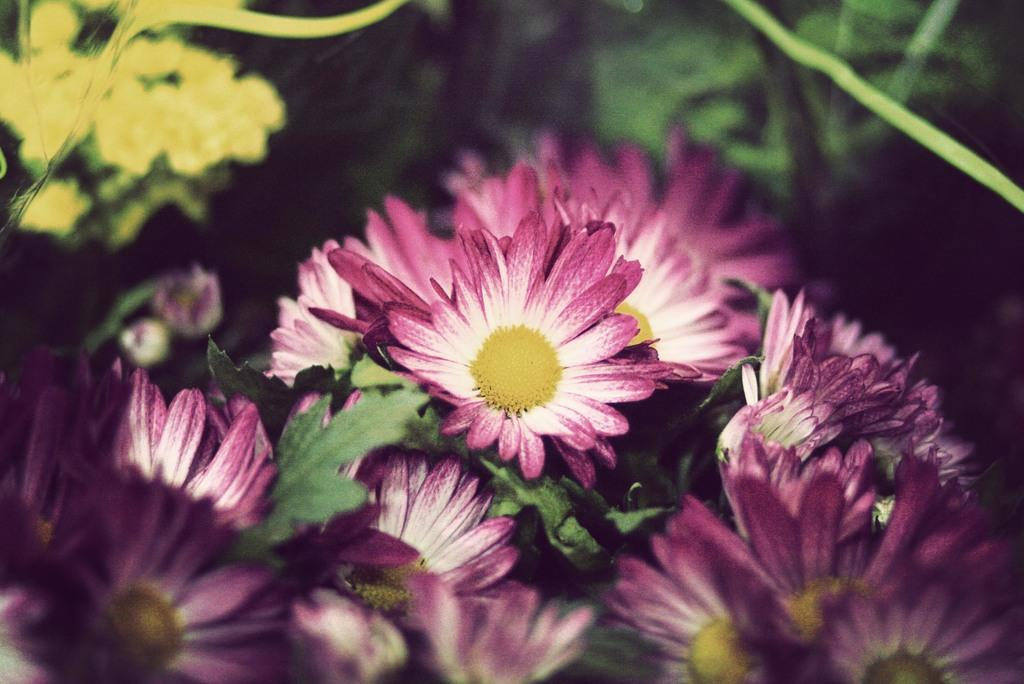What type of living organisms can be seen in the image? Plants and flowers are visible in the image. Can you describe the flowers in the image? The flowers in the image are colorful and appear to be in bloom. What message of hope can be seen in the image? There is no specific message of hope present in the image; it simply features plants and flowers. 